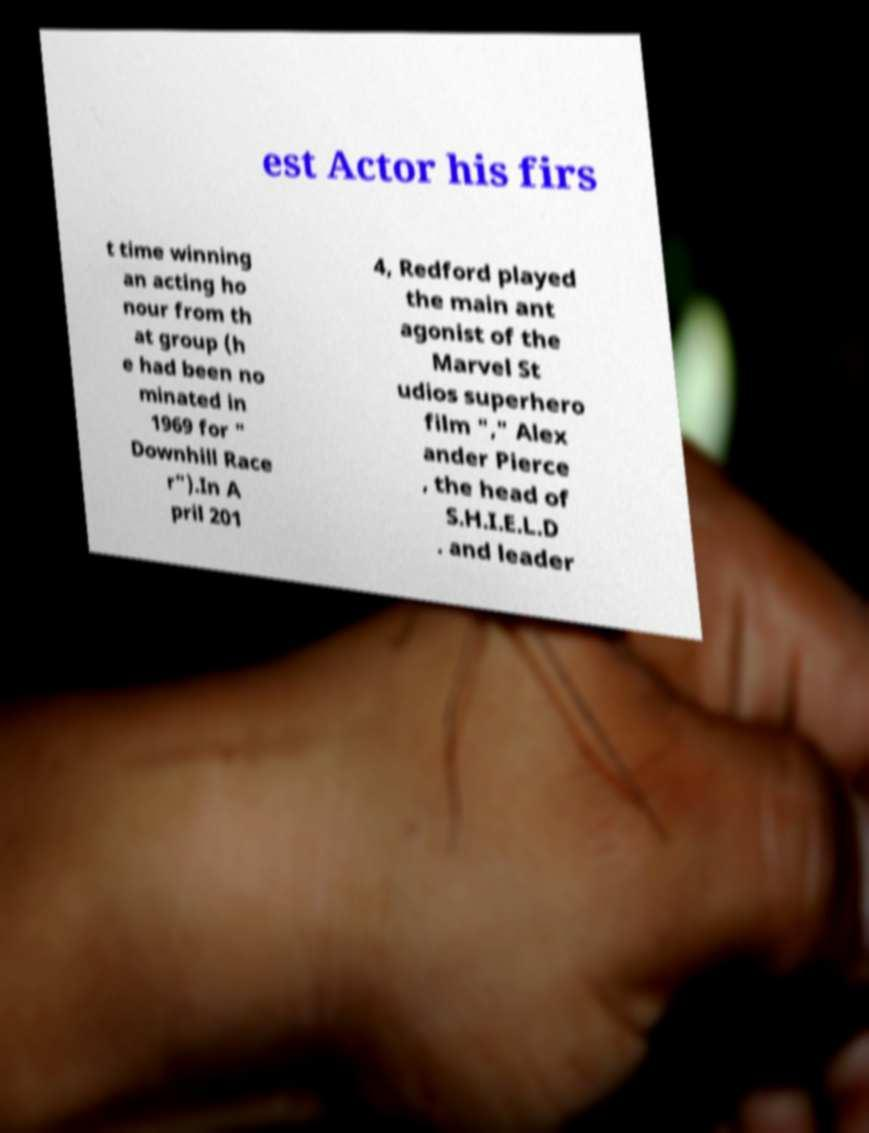Could you extract and type out the text from this image? est Actor his firs t time winning an acting ho nour from th at group (h e had been no minated in 1969 for " Downhill Race r").In A pril 201 4, Redford played the main ant agonist of the Marvel St udios superhero film "," Alex ander Pierce , the head of S.H.I.E.L.D . and leader 